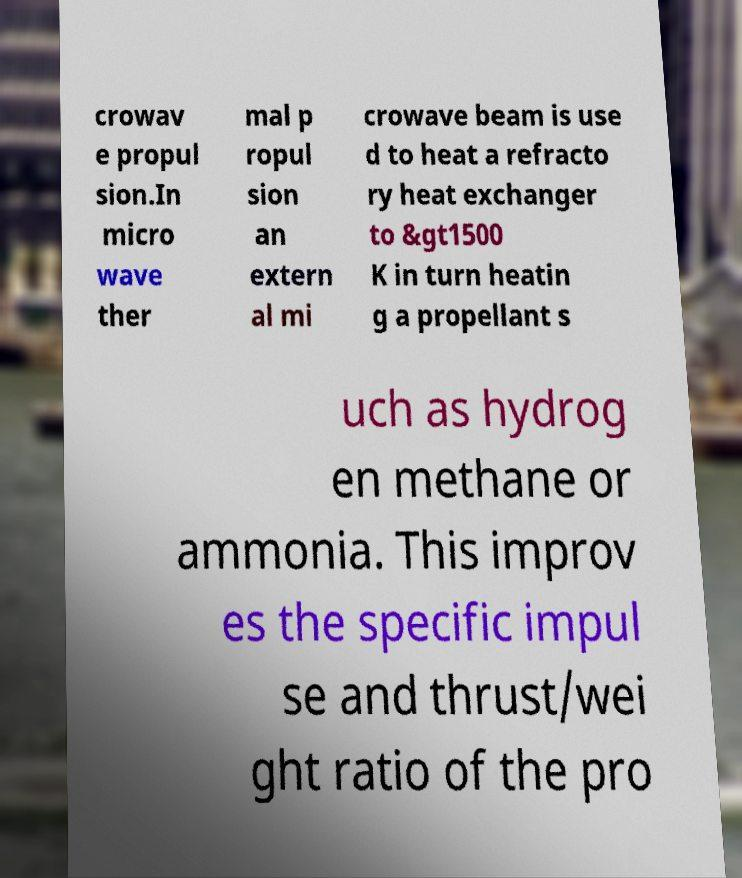What messages or text are displayed in this image? I need them in a readable, typed format. crowav e propul sion.In micro wave ther mal p ropul sion an extern al mi crowave beam is use d to heat a refracto ry heat exchanger to &gt1500 K in turn heatin g a propellant s uch as hydrog en methane or ammonia. This improv es the specific impul se and thrust/wei ght ratio of the pro 